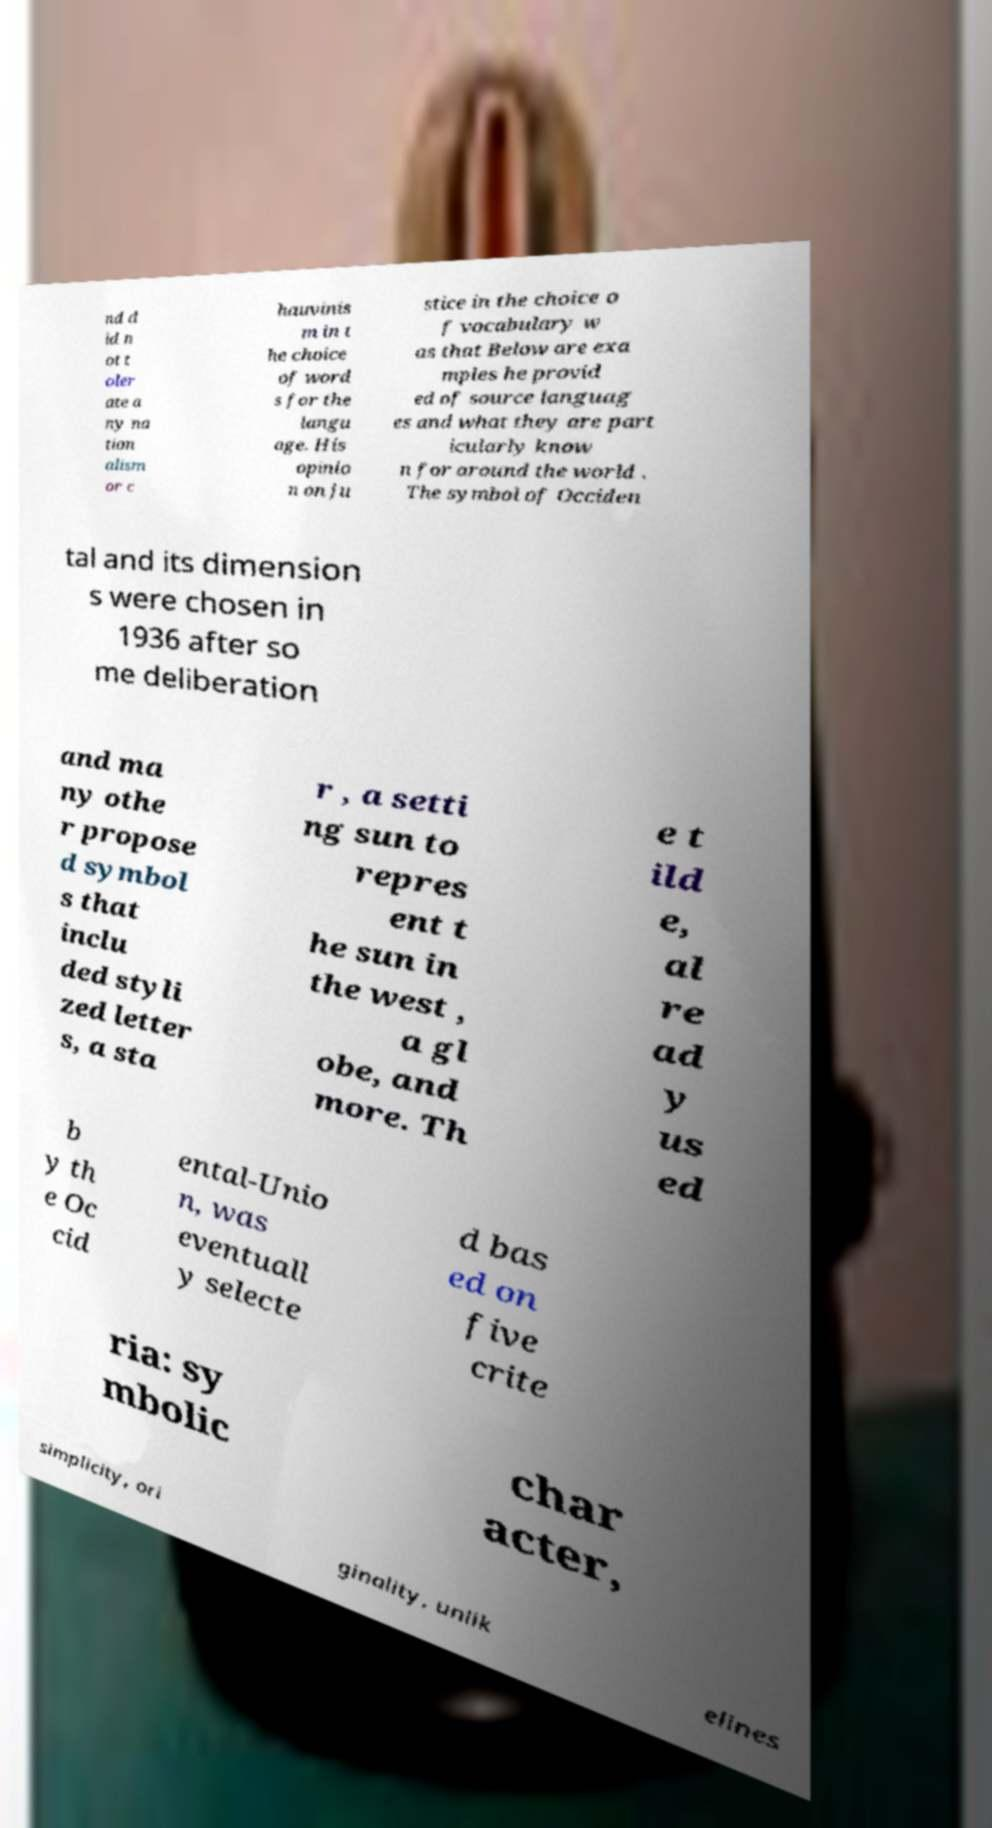Could you extract and type out the text from this image? nd d id n ot t oler ate a ny na tion alism or c hauvinis m in t he choice of word s for the langu age. His opinio n on ju stice in the choice o f vocabulary w as that Below are exa mples he provid ed of source languag es and what they are part icularly know n for around the world . The symbol of Occiden tal and its dimension s were chosen in 1936 after so me deliberation and ma ny othe r propose d symbol s that inclu ded styli zed letter s, a sta r , a setti ng sun to repres ent t he sun in the west , a gl obe, and more. Th e t ild e, al re ad y us ed b y th e Oc cid ental-Unio n, was eventuall y selecte d bas ed on five crite ria: sy mbolic char acter, simplicity, ori ginality, unlik elines 